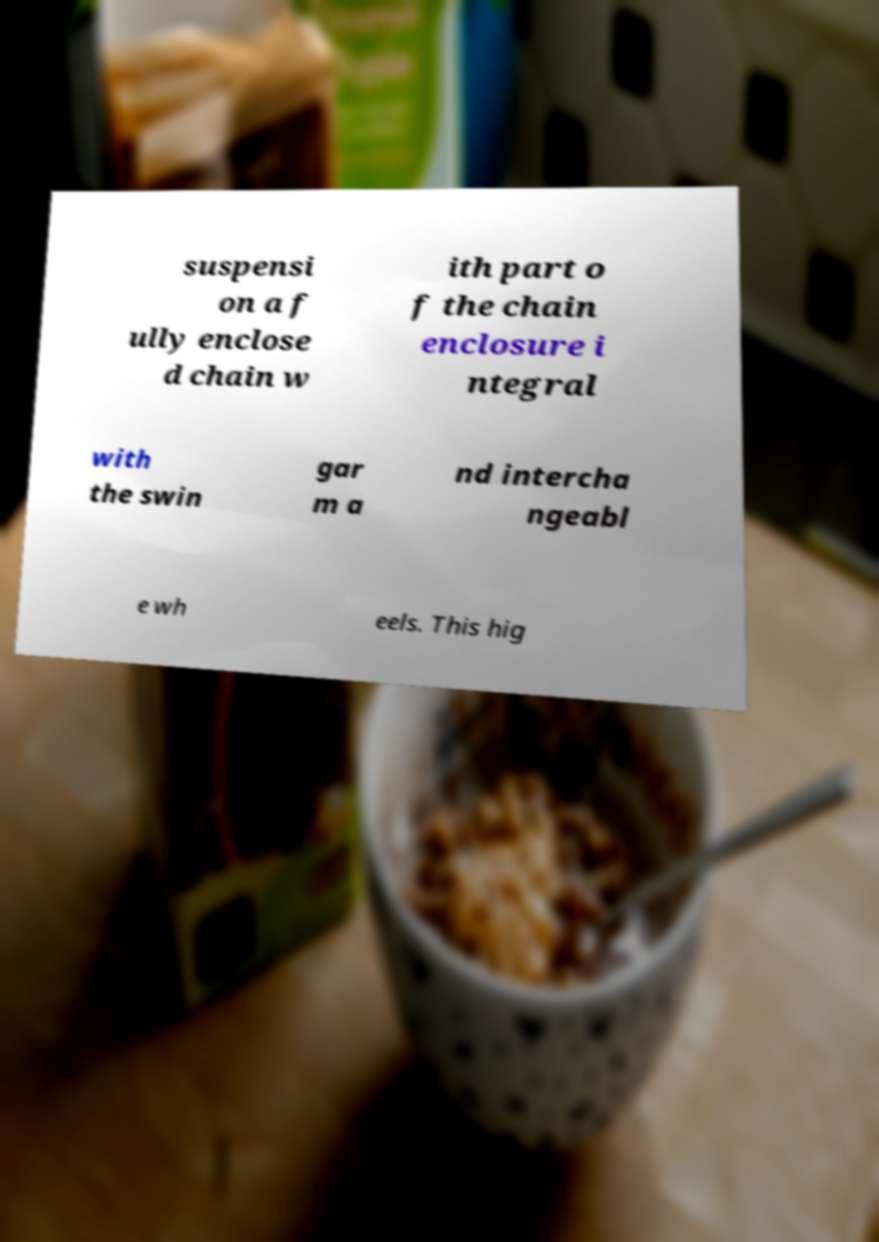Please read and relay the text visible in this image. What does it say? suspensi on a f ully enclose d chain w ith part o f the chain enclosure i ntegral with the swin gar m a nd intercha ngeabl e wh eels. This hig 